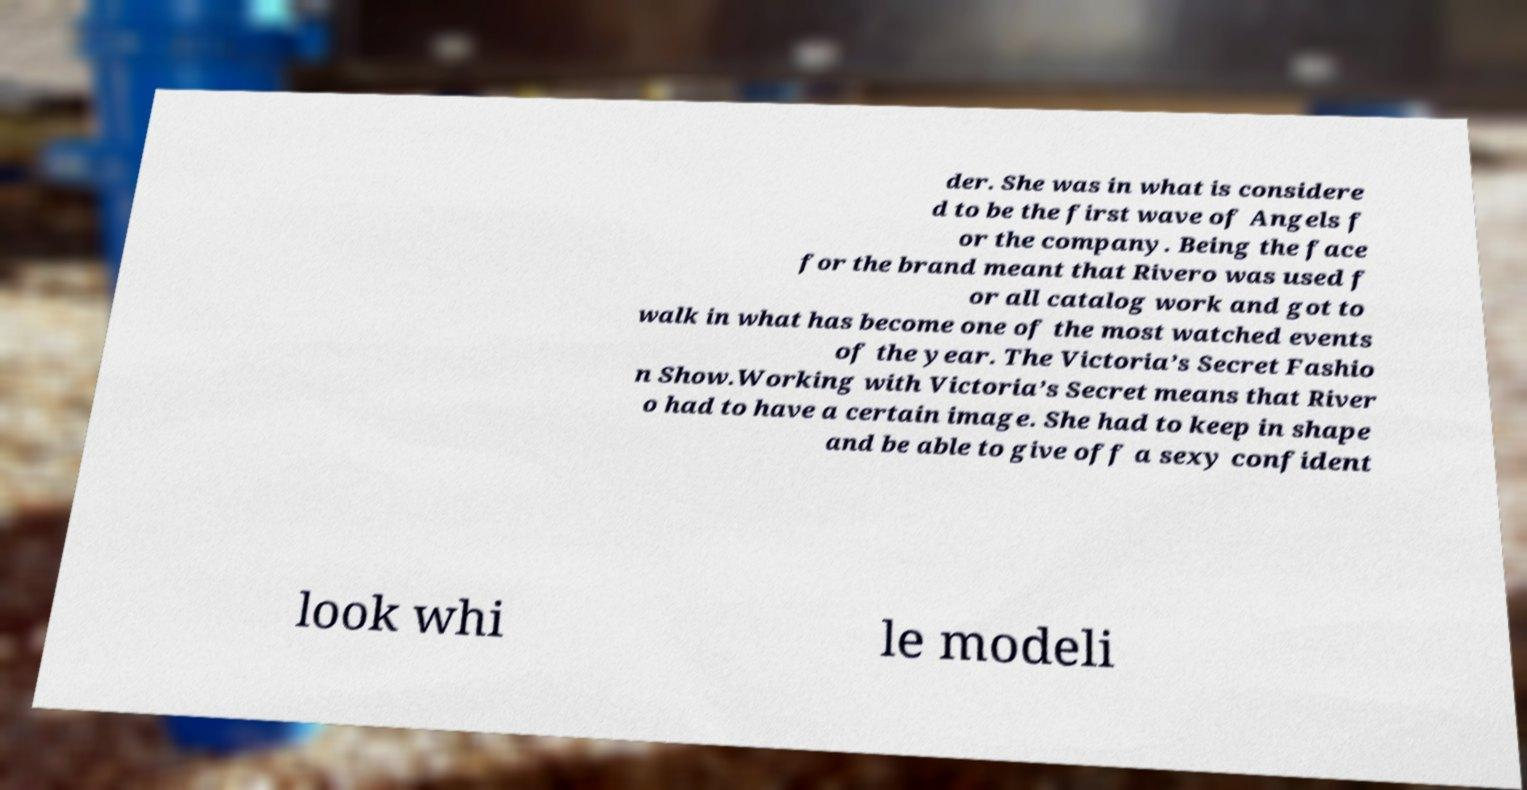Could you extract and type out the text from this image? der. She was in what is considere d to be the first wave of Angels f or the company. Being the face for the brand meant that Rivero was used f or all catalog work and got to walk in what has become one of the most watched events of the year. The Victoria’s Secret Fashio n Show.Working with Victoria’s Secret means that River o had to have a certain image. She had to keep in shape and be able to give off a sexy confident look whi le modeli 